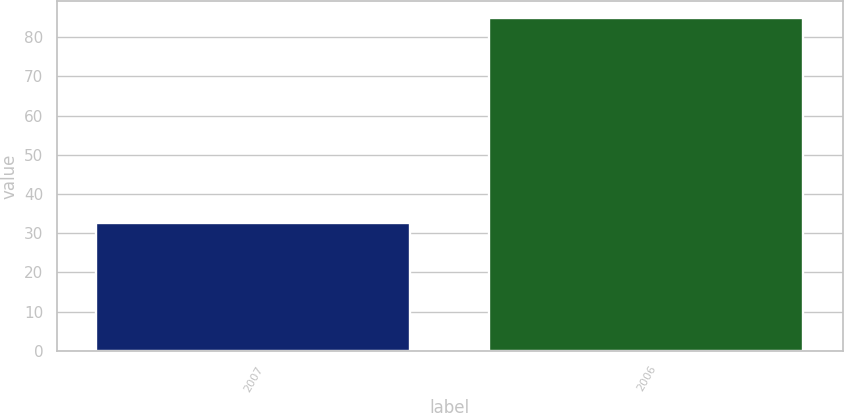Convert chart to OTSL. <chart><loc_0><loc_0><loc_500><loc_500><bar_chart><fcel>2007<fcel>2006<nl><fcel>32.5<fcel>85<nl></chart> 